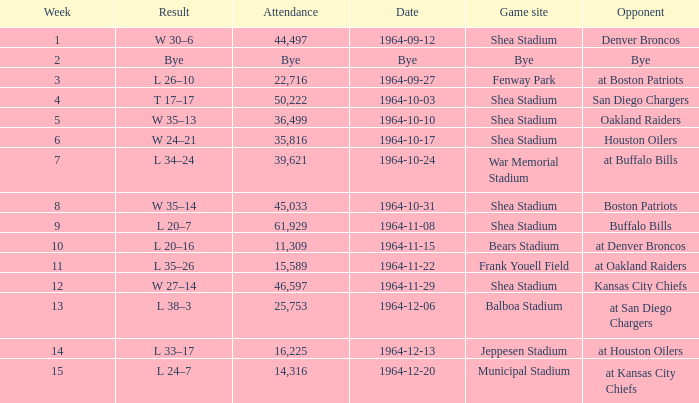Where did the Jet's play with an attendance of 11,309? Bears Stadium. 